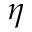Convert formula to latex. <formula><loc_0><loc_0><loc_500><loc_500>\eta</formula> 